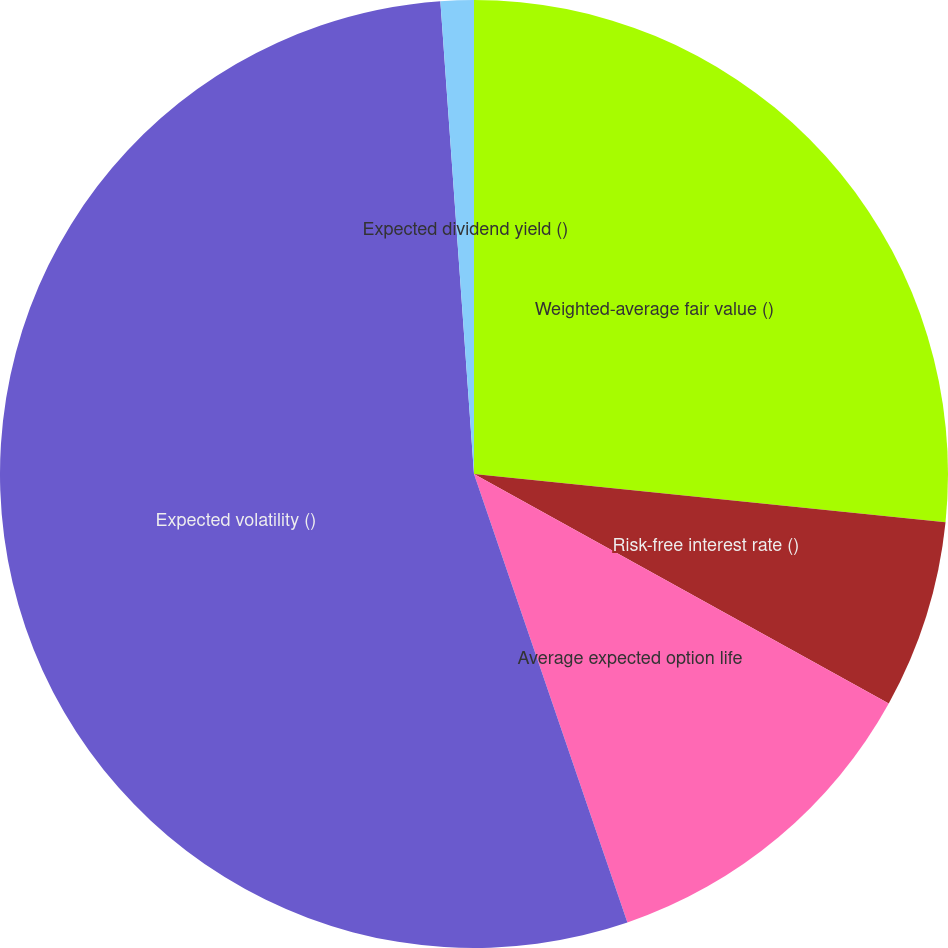Convert chart to OTSL. <chart><loc_0><loc_0><loc_500><loc_500><pie_chart><fcel>Weighted-average fair value ()<fcel>Risk-free interest rate ()<fcel>Average expected option life<fcel>Expected volatility ()<fcel>Expected dividend yield ()<nl><fcel>26.62%<fcel>6.42%<fcel>11.71%<fcel>54.11%<fcel>1.13%<nl></chart> 